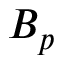Convert formula to latex. <formula><loc_0><loc_0><loc_500><loc_500>B _ { p }</formula> 